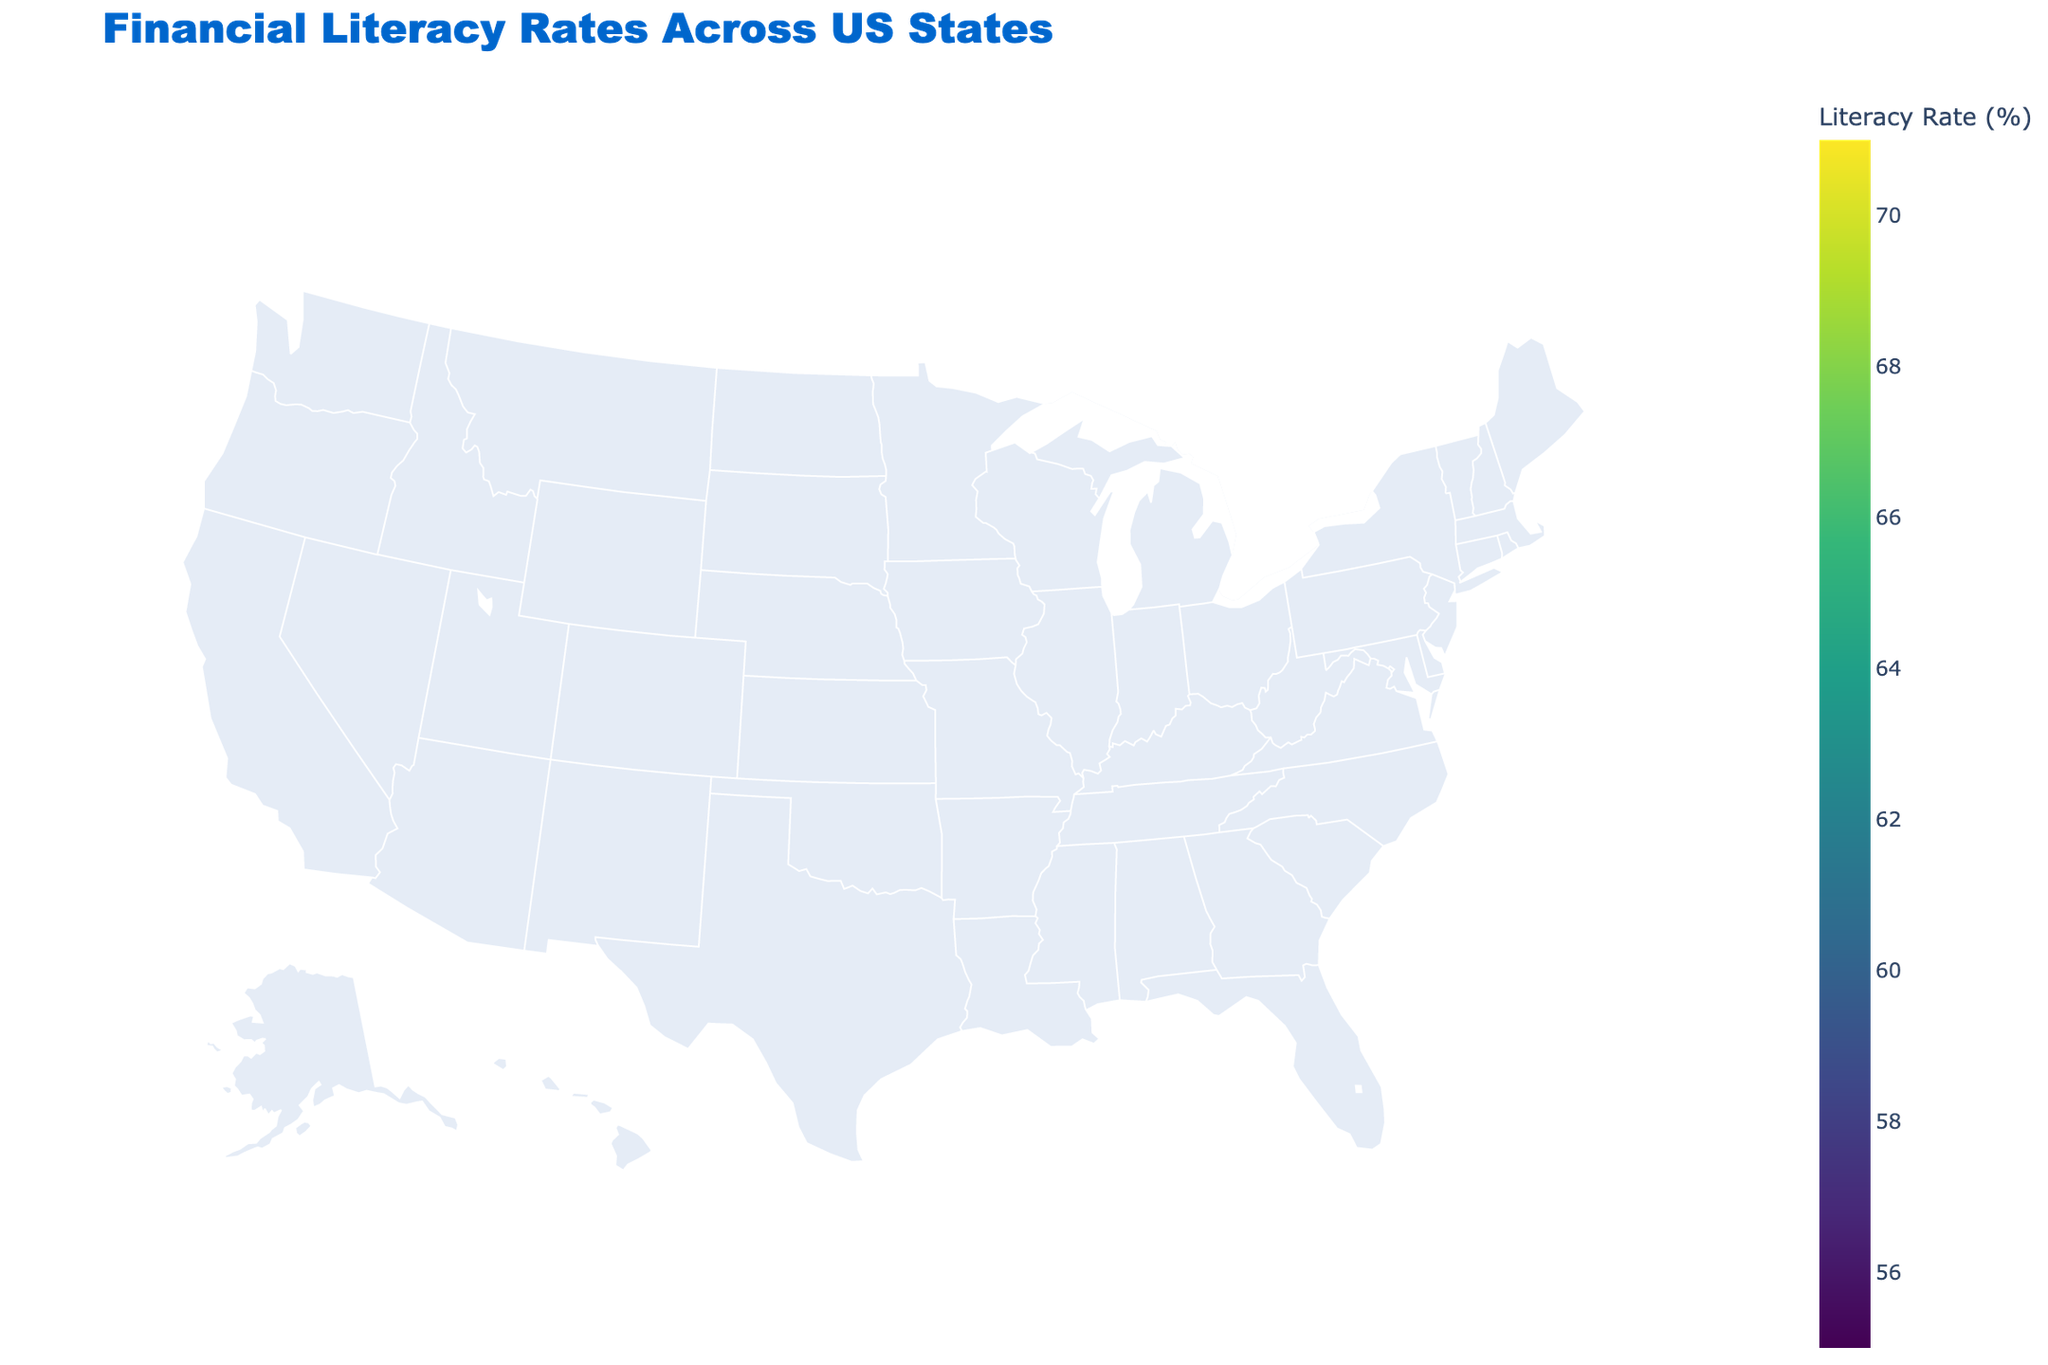Which state has the highest financial literacy rate? The title indicates the map shows financial literacy rates across US states. The color scheme represents the rates, and Massachusetts has the darkest color, indicating the highest rate.
Answer: Massachusetts What is the financial literacy rate of California? The figure highlights each state's rate when hovered over, and California's rate is shown to be 65%.
Answer: 65% Which states have financial literacy rates below 60%? Observing the map color scheme, the states with lighter colors signify lower rates. Alabama, Arkansas, Kentucky, Louisiana, Mississippi, New Mexico, Oklahoma, and West Virginia fall below 60%.
Answer: Alabama, Arkansas, Kentucky, Louisiana, Mississippi, New Mexico, Oklahoma, West Virginia What is the average financial literacy rate of states in the Northeast? The Northeast includes states like Connecticut (70), Massachusetts (71), Maine (65), New Hampshire (69), New Jersey (68), New York (67), Pennsylvania (66), Rhode Island (67), and Vermont (68). Summing their rates and dividing by 9 gives the average. (70+71+65+69+68+67+66+67+68)/9 = 611/9 ≈ 67.9
Answer: 67.9 How does the financial literacy rate of Colorado compare to that of Texas? Colorado’s rate is 68% while Texas has 62%, making Colorado's rate higher.
Answer: Colorado's rate is higher What is the range of financial literacy rates across all states? The range is calculated by subtracting the lowest rate from the highest rate. Massachusetts has the highest rate (71%), and Mississippi has the lowest (55%). 71 - 55 = 16
Answer: 16 Are there more states with financial literacy rates above or below the median rate? The median rate of the given data set is around 64%. Counting the states, 24 have rates above 64%, and 26 are below.
Answer: Below Which region has the highest concentration of states with financial literacy rates above 65%? Most states in the Northeast (e.g., Connecticut, Massachusetts, and Vermont) have rates above 65%, indicating a high concentration in this region.
Answer: Northeast What is the financial literacy rate difference between Illinois and Alabama? Illinois has a rate of 66% while Alabama has 59%. So the difference is 66 - 59 = 7.
Answer: 7 